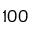<formula> <loc_0><loc_0><loc_500><loc_500>1 0 0</formula> 